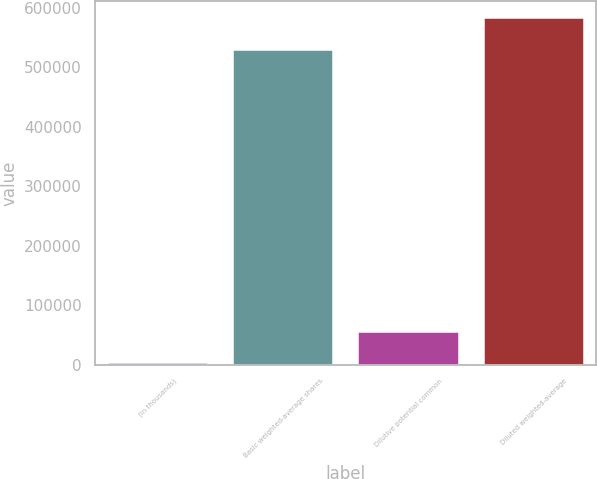Convert chart. <chart><loc_0><loc_0><loc_500><loc_500><bar_chart><fcel>(in thousands)<fcel>Basic weighted-average shares<fcel>Dilutive potential common<fcel>Diluted weighted-average<nl><fcel>2017<fcel>528363<fcel>55726.9<fcel>582073<nl></chart> 